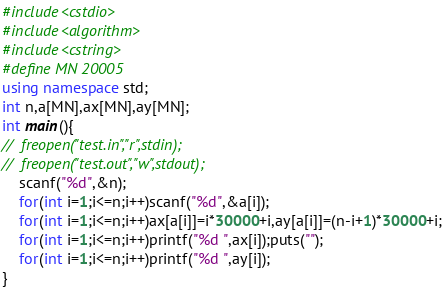<code> <loc_0><loc_0><loc_500><loc_500><_C++_>#include<cstdio>
#include<algorithm>
#include<cstring>
#define MN 20005
using namespace std;
int n,a[MN],ax[MN],ay[MN];
int main(){
//	freopen("test.in","r",stdin);
//	freopen("test.out","w",stdout);
	scanf("%d",&n);
	for(int i=1;i<=n;i++)scanf("%d",&a[i]);
	for(int i=1;i<=n;i++)ax[a[i]]=i*30000+i,ay[a[i]]=(n-i+1)*30000+i;
	for(int i=1;i<=n;i++)printf("%d ",ax[i]);puts("");
	for(int i=1;i<=n;i++)printf("%d ",ay[i]);
}</code> 